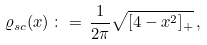Convert formula to latex. <formula><loc_0><loc_0><loc_500><loc_500>\varrho _ { s c } ( x ) \, \colon = \, \frac { 1 } { 2 \pi } \sqrt { [ 4 - x ^ { 2 } ] _ { + } } \, ,</formula> 